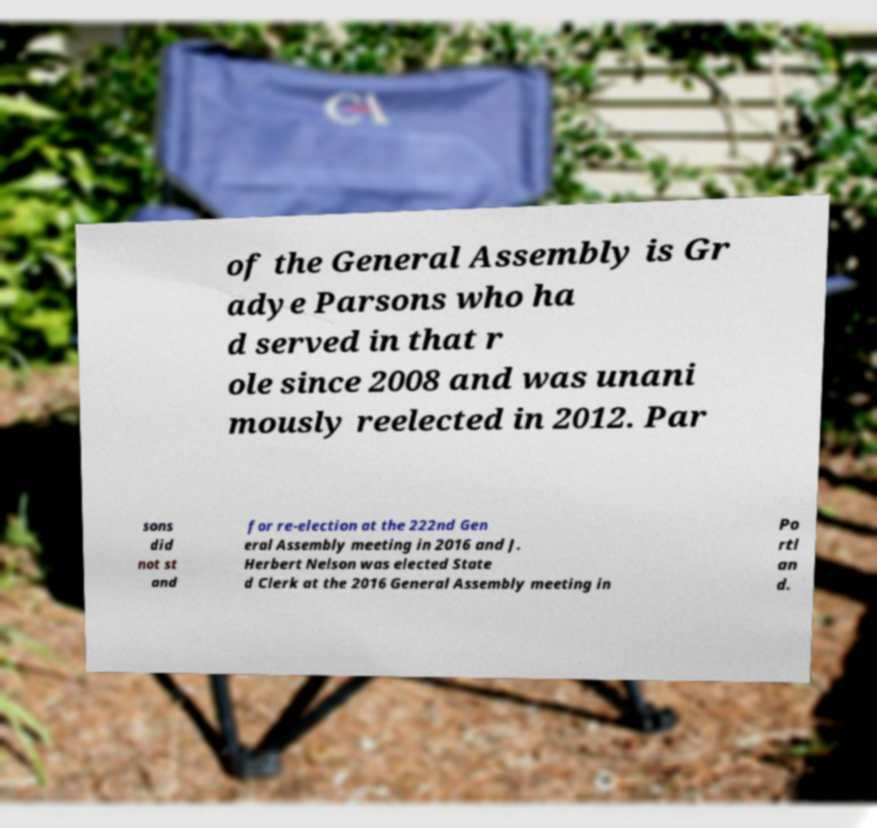What messages or text are displayed in this image? I need them in a readable, typed format. of the General Assembly is Gr adye Parsons who ha d served in that r ole since 2008 and was unani mously reelected in 2012. Par sons did not st and for re-election at the 222nd Gen eral Assembly meeting in 2016 and J. Herbert Nelson was elected State d Clerk at the 2016 General Assembly meeting in Po rtl an d. 